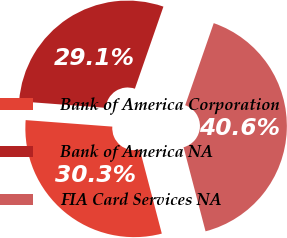Convert chart. <chart><loc_0><loc_0><loc_500><loc_500><pie_chart><fcel>Bank of America Corporation<fcel>Bank of America NA<fcel>FIA Card Services NA<nl><fcel>30.27%<fcel>29.13%<fcel>40.6%<nl></chart> 